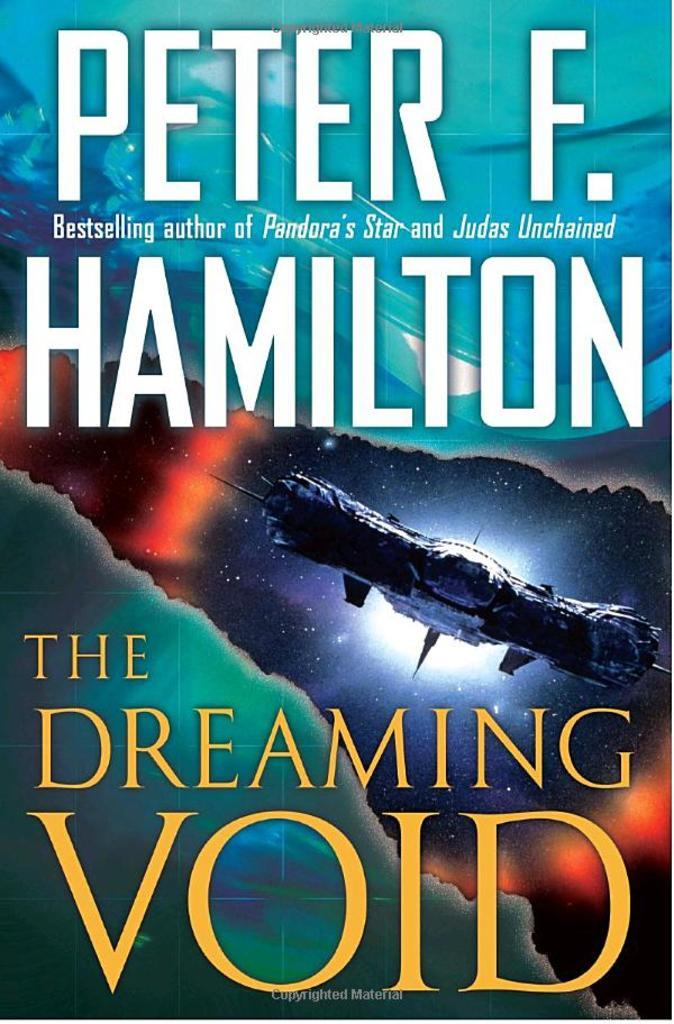<image>
Provide a brief description of the given image. The cover of Peter F. Hamilton's book The Dreaming Void. 